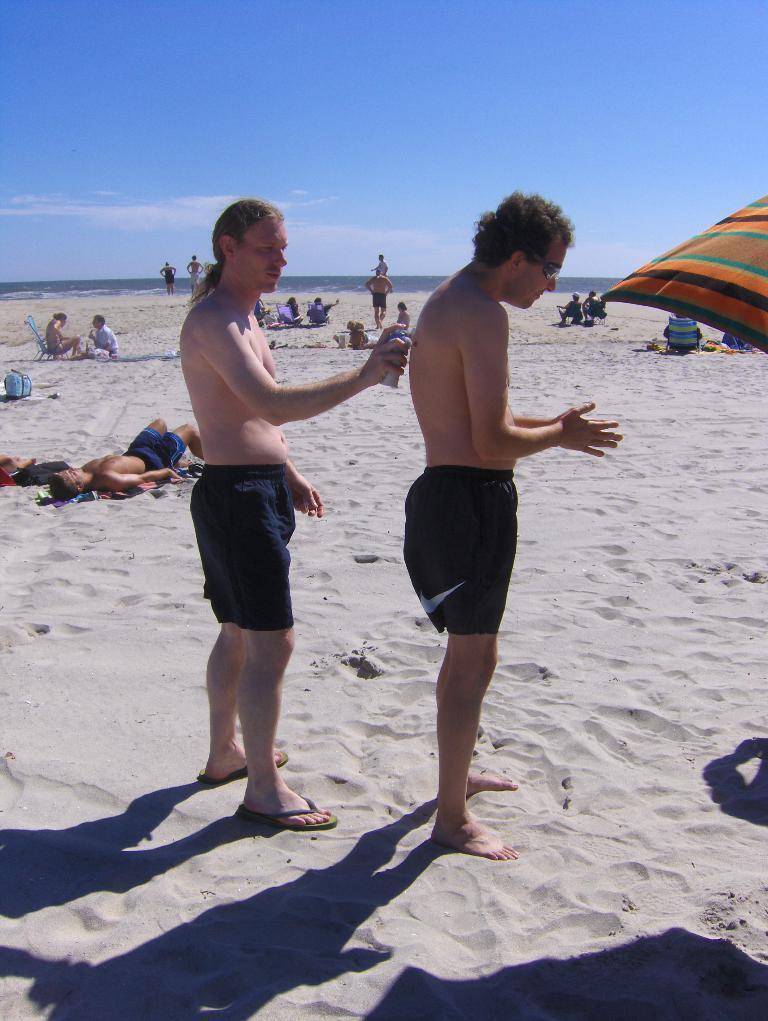Could you give a brief overview of what you see in this image? In the center of the image we can see two people standing. On the left we can see a man standing and holding a tin. At the bottom there is sand and we can see people lying on the sand. Some of them are sitting and standing. In the background there is water and we can see sky. On the right there is a parasol. 